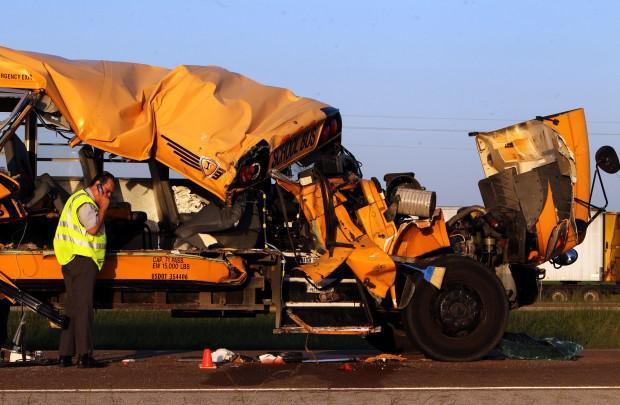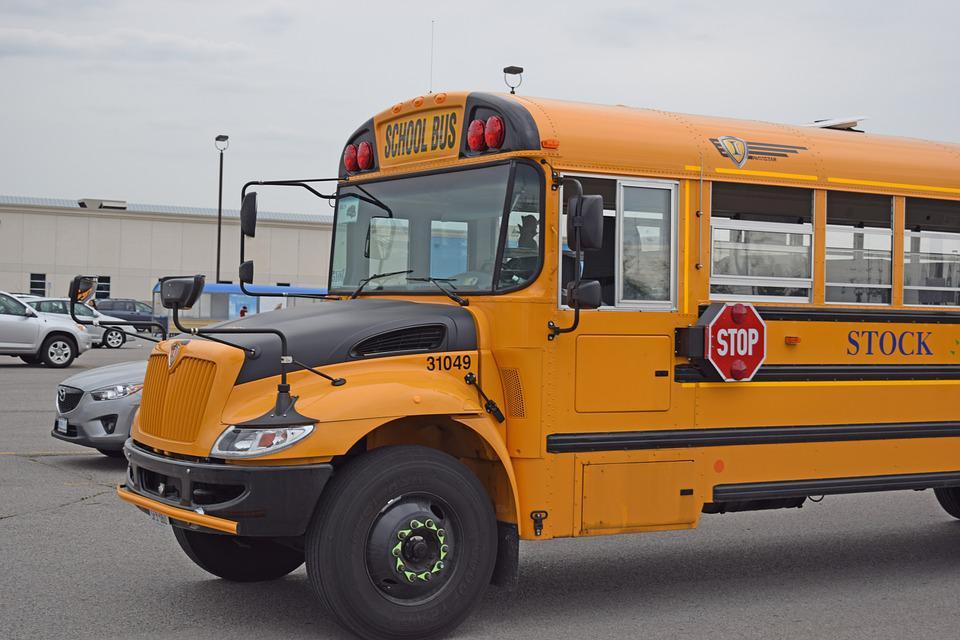The first image is the image on the left, the second image is the image on the right. Given the left and right images, does the statement "All school buses are intact and angled heading rightward, with no buildings visible behind them." hold true? Answer yes or no. No. 